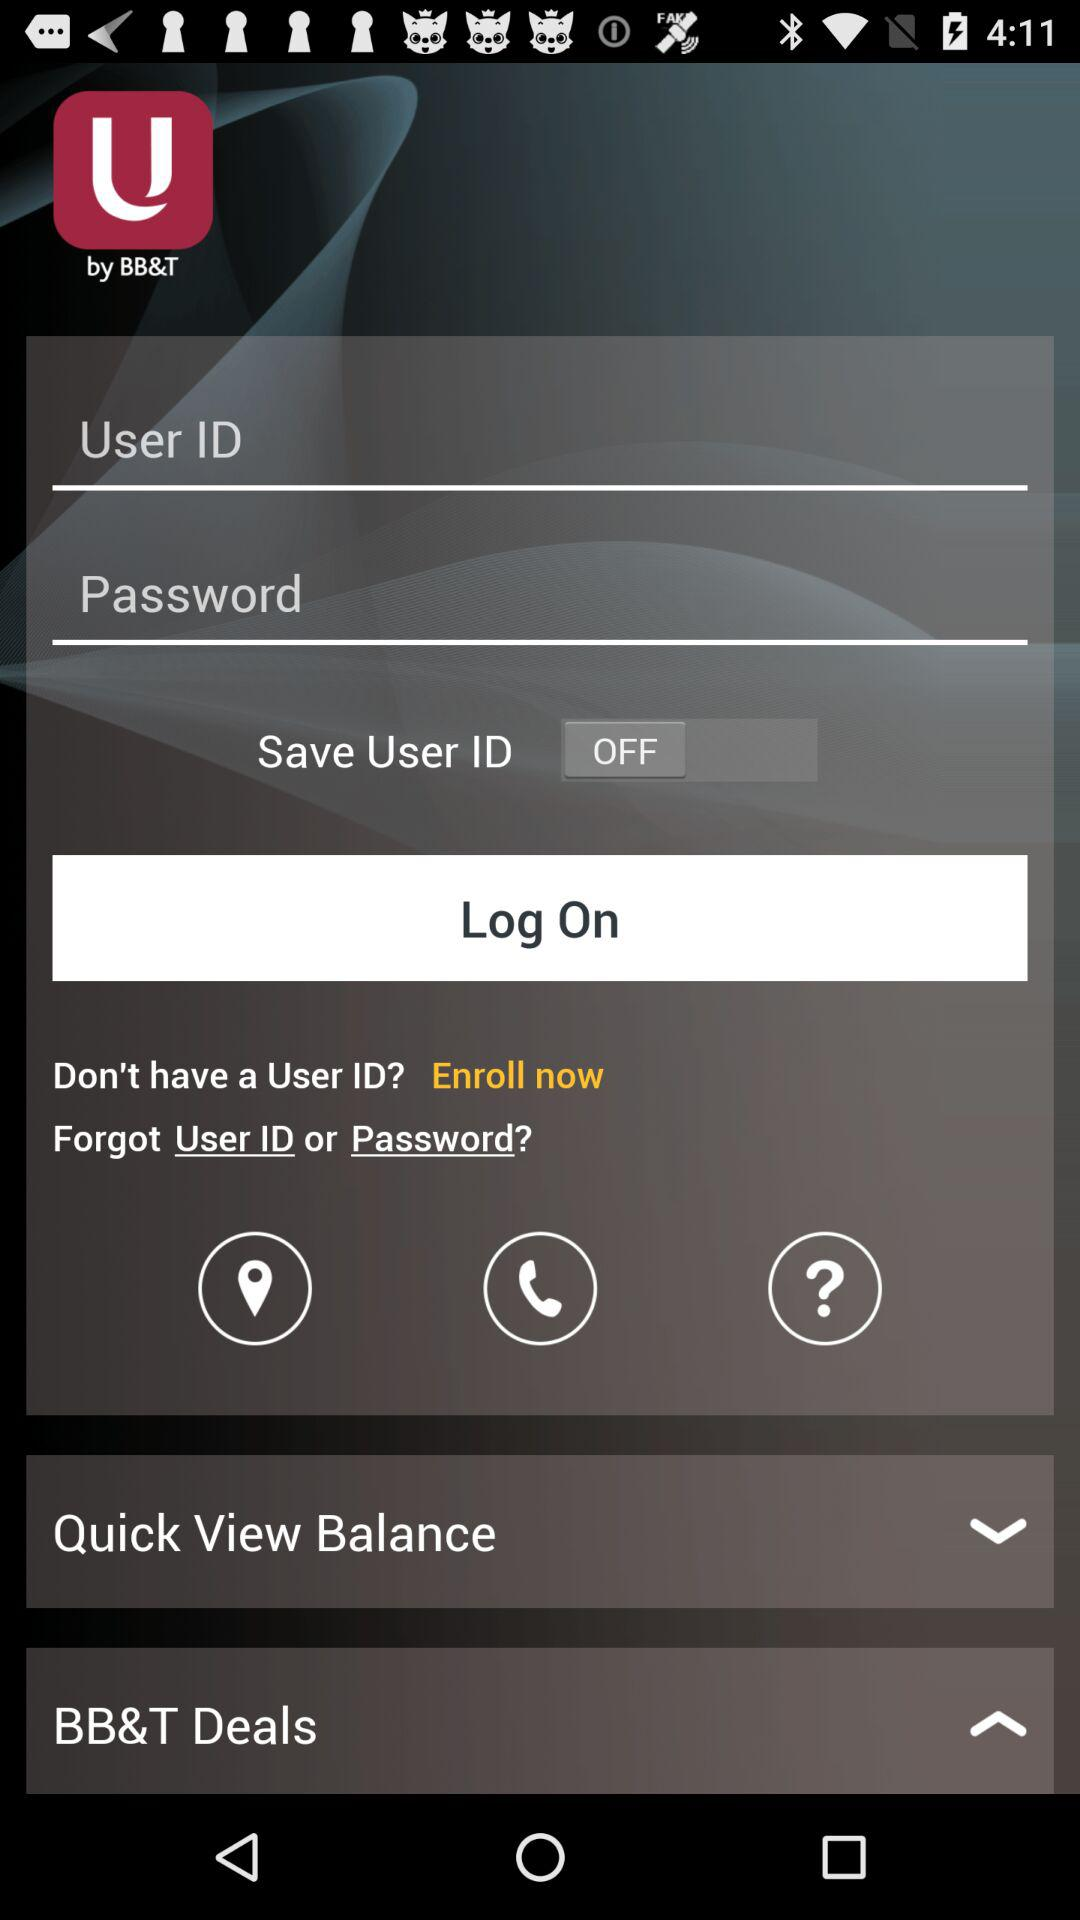How many characters are required to create a password?
When the provided information is insufficient, respond with <no answer>. <no answer> 